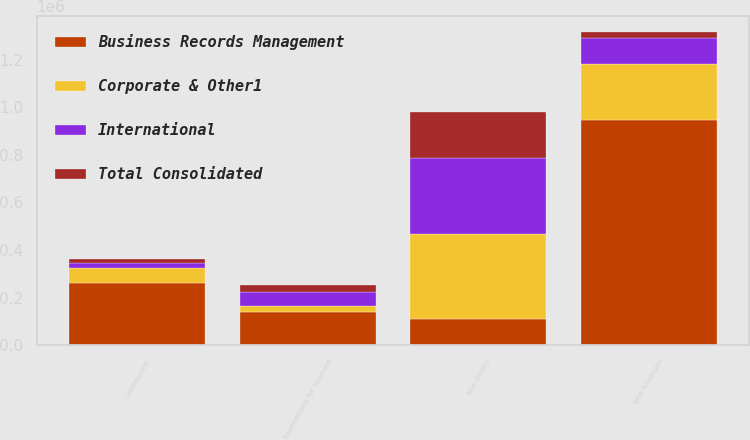Convert chart to OTSL. <chart><loc_0><loc_0><loc_500><loc_500><stacked_bar_chart><ecel><fcel>Total Revenues<fcel>Contribution<fcel>Total Assets<fcel>Expenditures for Segment<nl><fcel>Business Records Management<fcel>944845<fcel>262541<fcel>109381<fcel>141663<nl><fcel>Corporate & Other1<fcel>239081<fcel>61729<fcel>359339<fcel>24642<nl><fcel>International<fcel>109381<fcel>21988<fcel>317073<fcel>58107<nl><fcel>Total Consolidated<fcel>25190<fcel>16890<fcel>195784<fcel>30365<nl></chart> 